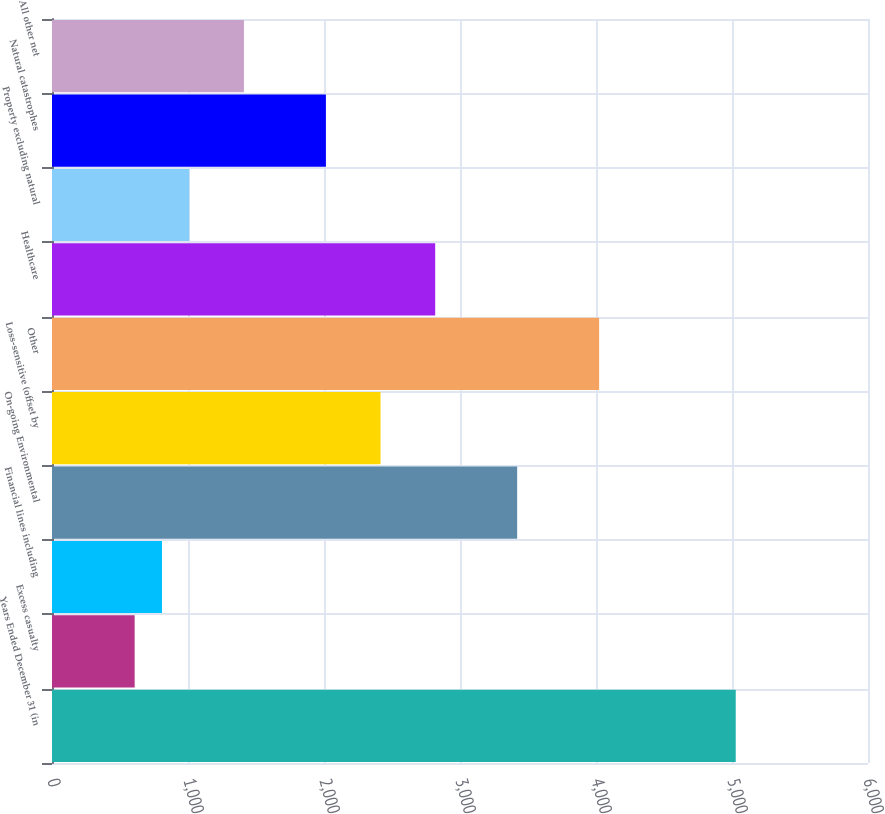Convert chart to OTSL. <chart><loc_0><loc_0><loc_500><loc_500><bar_chart><fcel>Years Ended December 31 (in<fcel>Excess casualty<fcel>Financial lines including<fcel>On-going Environmental<fcel>Loss-sensitive (offset by<fcel>Other<fcel>Healthcare<fcel>Property excluding natural<fcel>Natural catastrophes<fcel>All other net<nl><fcel>5027.5<fcel>607.7<fcel>808.6<fcel>3420.3<fcel>2415.8<fcel>4023<fcel>2817.6<fcel>1009.5<fcel>2014<fcel>1411.3<nl></chart> 